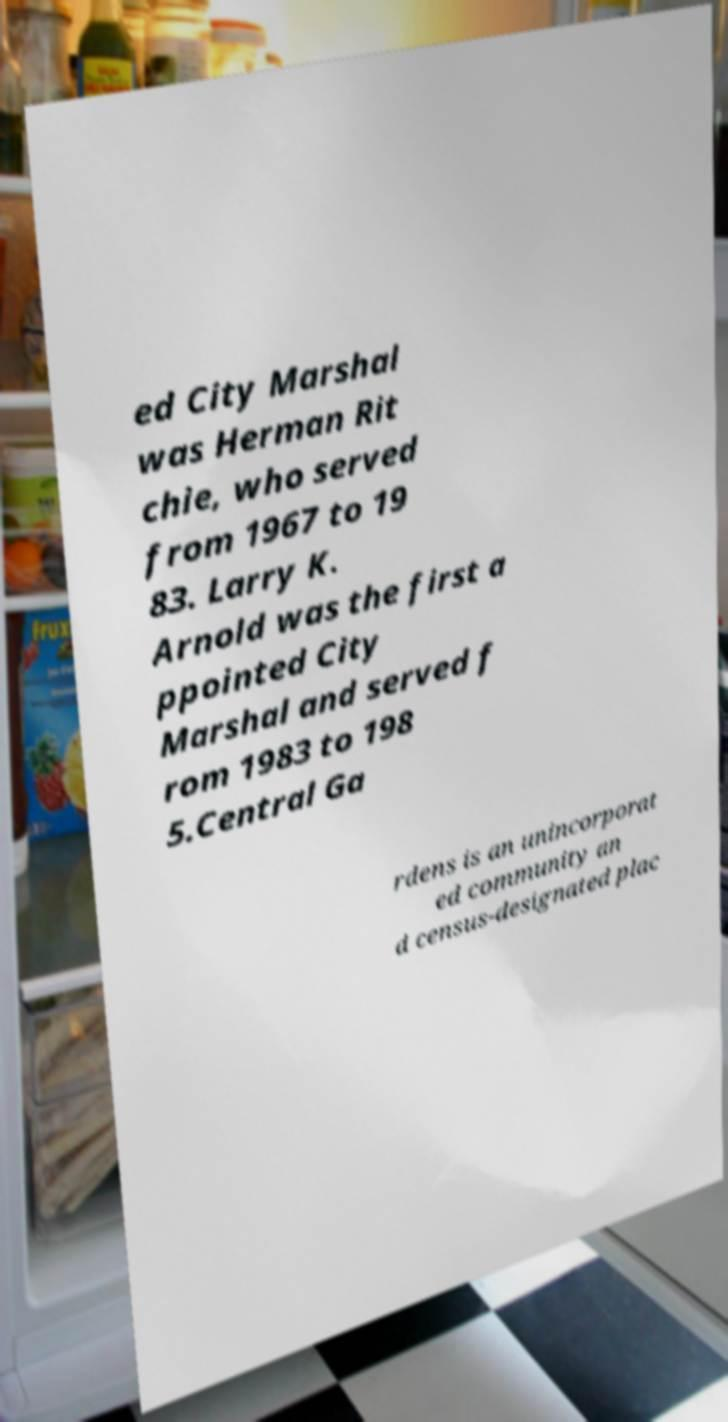There's text embedded in this image that I need extracted. Can you transcribe it verbatim? ed City Marshal was Herman Rit chie, who served from 1967 to 19 83. Larry K. Arnold was the first a ppointed City Marshal and served f rom 1983 to 198 5.Central Ga rdens is an unincorporat ed community an d census-designated plac 